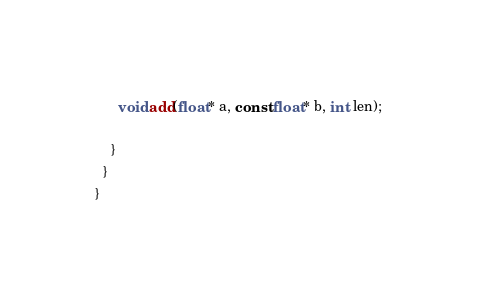<code> <loc_0><loc_0><loc_500><loc_500><_Cuda_>      void add(float* a, const float* b, int len);

    }
  }
}
</code> 